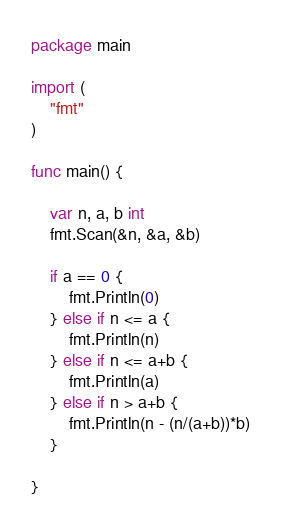Convert code to text. <code><loc_0><loc_0><loc_500><loc_500><_Go_>package main

import (
	"fmt"
)

func main() {

	var n, a, b int
	fmt.Scan(&n, &a, &b)

	if a == 0 {
		fmt.Println(0)
	} else if n <= a {
		fmt.Println(n)
	} else if n <= a+b {
		fmt.Println(a)
	} else if n > a+b {
		fmt.Println(n - (n/(a+b))*b)
	}

}</code> 